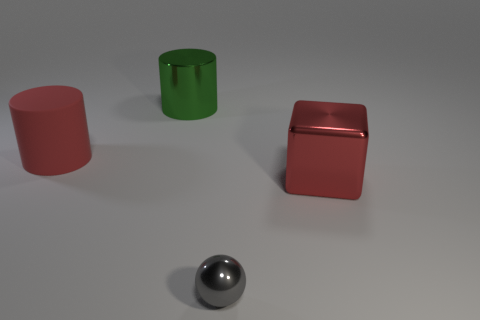Add 3 large purple metallic cylinders. How many objects exist? 7 Subtract all balls. How many objects are left? 3 Add 2 green shiny cylinders. How many green shiny cylinders are left? 3 Add 2 big cylinders. How many big cylinders exist? 4 Subtract 0 gray blocks. How many objects are left? 4 Subtract all large green metal things. Subtract all small gray metallic balls. How many objects are left? 2 